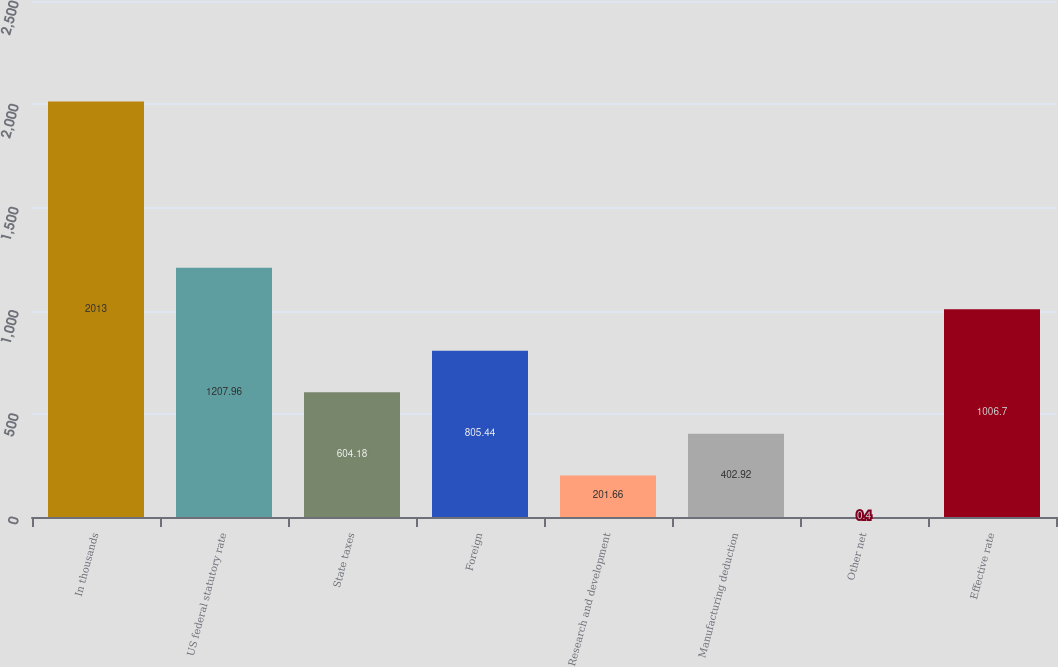<chart> <loc_0><loc_0><loc_500><loc_500><bar_chart><fcel>In thousands<fcel>US federal statutory rate<fcel>State taxes<fcel>Foreign<fcel>Research and development<fcel>Manufacturing deduction<fcel>Other net<fcel>Effective rate<nl><fcel>2013<fcel>1207.96<fcel>604.18<fcel>805.44<fcel>201.66<fcel>402.92<fcel>0.4<fcel>1006.7<nl></chart> 